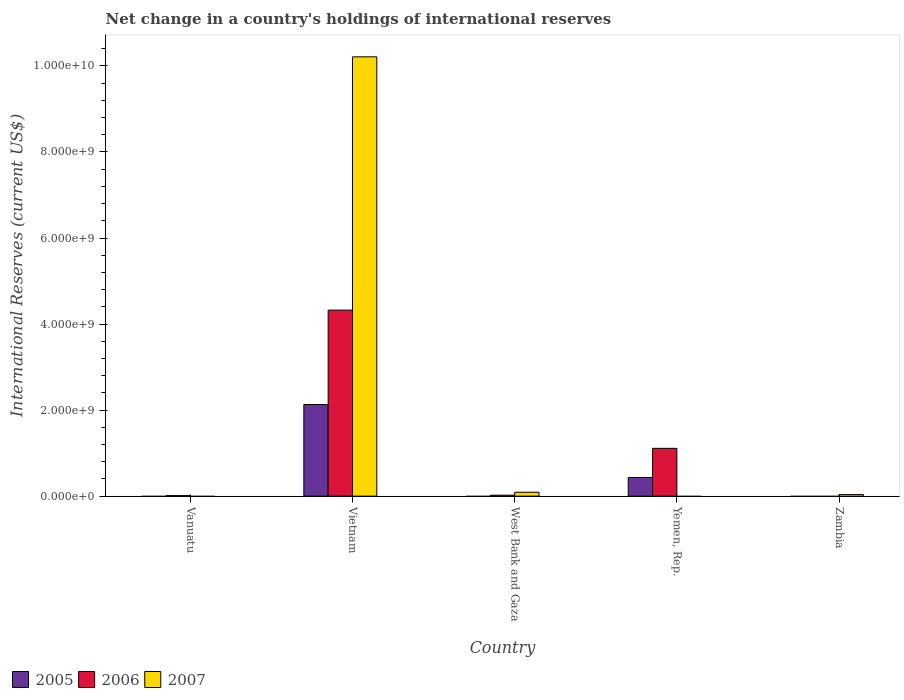What is the label of the 5th group of bars from the left?
Offer a very short reply. Zambia. In how many cases, is the number of bars for a given country not equal to the number of legend labels?
Your answer should be very brief. 4. What is the international reserves in 2007 in West Bank and Gaza?
Offer a terse response. 9.13e+07. Across all countries, what is the maximum international reserves in 2006?
Your response must be concise. 4.32e+09. Across all countries, what is the minimum international reserves in 2005?
Your answer should be compact. 0. In which country was the international reserves in 2005 maximum?
Your answer should be very brief. Vietnam. What is the total international reserves in 2005 in the graph?
Make the answer very short. 2.56e+09. What is the difference between the international reserves in 2006 in Vanuatu and that in Vietnam?
Offer a very short reply. -4.31e+09. What is the difference between the international reserves in 2007 in Vietnam and the international reserves in 2006 in Zambia?
Provide a succinct answer. 1.02e+1. What is the average international reserves in 2006 per country?
Your response must be concise. 1.09e+09. What is the difference between the international reserves of/in 2005 and international reserves of/in 2006 in Vietnam?
Make the answer very short. -2.19e+09. What is the ratio of the international reserves in 2005 in Vietnam to that in Yemen, Rep.?
Make the answer very short. 4.91. Is the international reserves in 2006 in West Bank and Gaza less than that in Yemen, Rep.?
Your response must be concise. Yes. What is the difference between the highest and the second highest international reserves in 2007?
Provide a succinct answer. -1.01e+1. What is the difference between the highest and the lowest international reserves in 2007?
Provide a succinct answer. 1.02e+1. In how many countries, is the international reserves in 2006 greater than the average international reserves in 2006 taken over all countries?
Give a very brief answer. 2. Is it the case that in every country, the sum of the international reserves in 2005 and international reserves in 2007 is greater than the international reserves in 2006?
Offer a very short reply. No. Are all the bars in the graph horizontal?
Make the answer very short. No. How many countries are there in the graph?
Ensure brevity in your answer.  5. What is the difference between two consecutive major ticks on the Y-axis?
Your answer should be compact. 2.00e+09. How many legend labels are there?
Provide a short and direct response. 3. How are the legend labels stacked?
Keep it short and to the point. Horizontal. What is the title of the graph?
Provide a short and direct response. Net change in a country's holdings of international reserves. What is the label or title of the X-axis?
Offer a terse response. Country. What is the label or title of the Y-axis?
Ensure brevity in your answer.  International Reserves (current US$). What is the International Reserves (current US$) in 2006 in Vanuatu?
Your response must be concise. 1.29e+07. What is the International Reserves (current US$) in 2005 in Vietnam?
Give a very brief answer. 2.13e+09. What is the International Reserves (current US$) in 2006 in Vietnam?
Provide a short and direct response. 4.32e+09. What is the International Reserves (current US$) in 2007 in Vietnam?
Keep it short and to the point. 1.02e+1. What is the International Reserves (current US$) in 2005 in West Bank and Gaza?
Your answer should be very brief. 0. What is the International Reserves (current US$) of 2006 in West Bank and Gaza?
Your answer should be compact. 2.23e+07. What is the International Reserves (current US$) in 2007 in West Bank and Gaza?
Provide a succinct answer. 9.13e+07. What is the International Reserves (current US$) in 2005 in Yemen, Rep.?
Make the answer very short. 4.34e+08. What is the International Reserves (current US$) of 2006 in Yemen, Rep.?
Your response must be concise. 1.11e+09. What is the International Reserves (current US$) in 2005 in Zambia?
Make the answer very short. 0. What is the International Reserves (current US$) in 2007 in Zambia?
Give a very brief answer. 3.68e+07. Across all countries, what is the maximum International Reserves (current US$) of 2005?
Provide a short and direct response. 2.13e+09. Across all countries, what is the maximum International Reserves (current US$) in 2006?
Give a very brief answer. 4.32e+09. Across all countries, what is the maximum International Reserves (current US$) of 2007?
Make the answer very short. 1.02e+1. What is the total International Reserves (current US$) in 2005 in the graph?
Keep it short and to the point. 2.56e+09. What is the total International Reserves (current US$) of 2006 in the graph?
Ensure brevity in your answer.  5.47e+09. What is the total International Reserves (current US$) of 2007 in the graph?
Your response must be concise. 1.03e+1. What is the difference between the International Reserves (current US$) in 2006 in Vanuatu and that in Vietnam?
Your answer should be compact. -4.31e+09. What is the difference between the International Reserves (current US$) of 2006 in Vanuatu and that in West Bank and Gaza?
Provide a short and direct response. -9.43e+06. What is the difference between the International Reserves (current US$) in 2006 in Vanuatu and that in Yemen, Rep.?
Ensure brevity in your answer.  -1.10e+09. What is the difference between the International Reserves (current US$) of 2006 in Vietnam and that in West Bank and Gaza?
Your response must be concise. 4.30e+09. What is the difference between the International Reserves (current US$) of 2007 in Vietnam and that in West Bank and Gaza?
Your answer should be compact. 1.01e+1. What is the difference between the International Reserves (current US$) in 2005 in Vietnam and that in Yemen, Rep.?
Provide a short and direct response. 1.70e+09. What is the difference between the International Reserves (current US$) of 2006 in Vietnam and that in Yemen, Rep.?
Your response must be concise. 3.21e+09. What is the difference between the International Reserves (current US$) of 2007 in Vietnam and that in Zambia?
Make the answer very short. 1.02e+1. What is the difference between the International Reserves (current US$) of 2006 in West Bank and Gaza and that in Yemen, Rep.?
Your response must be concise. -1.09e+09. What is the difference between the International Reserves (current US$) of 2007 in West Bank and Gaza and that in Zambia?
Offer a very short reply. 5.45e+07. What is the difference between the International Reserves (current US$) of 2006 in Vanuatu and the International Reserves (current US$) of 2007 in Vietnam?
Your response must be concise. -1.02e+1. What is the difference between the International Reserves (current US$) of 2006 in Vanuatu and the International Reserves (current US$) of 2007 in West Bank and Gaza?
Give a very brief answer. -7.84e+07. What is the difference between the International Reserves (current US$) in 2006 in Vanuatu and the International Reserves (current US$) in 2007 in Zambia?
Provide a succinct answer. -2.39e+07. What is the difference between the International Reserves (current US$) of 2005 in Vietnam and the International Reserves (current US$) of 2006 in West Bank and Gaza?
Offer a terse response. 2.11e+09. What is the difference between the International Reserves (current US$) in 2005 in Vietnam and the International Reserves (current US$) in 2007 in West Bank and Gaza?
Provide a succinct answer. 2.04e+09. What is the difference between the International Reserves (current US$) in 2006 in Vietnam and the International Reserves (current US$) in 2007 in West Bank and Gaza?
Your answer should be compact. 4.23e+09. What is the difference between the International Reserves (current US$) of 2005 in Vietnam and the International Reserves (current US$) of 2006 in Yemen, Rep.?
Your answer should be very brief. 1.02e+09. What is the difference between the International Reserves (current US$) of 2005 in Vietnam and the International Reserves (current US$) of 2007 in Zambia?
Offer a very short reply. 2.09e+09. What is the difference between the International Reserves (current US$) in 2006 in Vietnam and the International Reserves (current US$) in 2007 in Zambia?
Give a very brief answer. 4.29e+09. What is the difference between the International Reserves (current US$) of 2006 in West Bank and Gaza and the International Reserves (current US$) of 2007 in Zambia?
Give a very brief answer. -1.45e+07. What is the difference between the International Reserves (current US$) in 2005 in Yemen, Rep. and the International Reserves (current US$) in 2007 in Zambia?
Ensure brevity in your answer.  3.97e+08. What is the difference between the International Reserves (current US$) of 2006 in Yemen, Rep. and the International Reserves (current US$) of 2007 in Zambia?
Provide a short and direct response. 1.07e+09. What is the average International Reserves (current US$) in 2005 per country?
Give a very brief answer. 5.13e+08. What is the average International Reserves (current US$) of 2006 per country?
Offer a terse response. 1.09e+09. What is the average International Reserves (current US$) in 2007 per country?
Offer a terse response. 2.07e+09. What is the difference between the International Reserves (current US$) of 2005 and International Reserves (current US$) of 2006 in Vietnam?
Your answer should be very brief. -2.19e+09. What is the difference between the International Reserves (current US$) of 2005 and International Reserves (current US$) of 2007 in Vietnam?
Your response must be concise. -8.08e+09. What is the difference between the International Reserves (current US$) of 2006 and International Reserves (current US$) of 2007 in Vietnam?
Your answer should be compact. -5.89e+09. What is the difference between the International Reserves (current US$) in 2006 and International Reserves (current US$) in 2007 in West Bank and Gaza?
Offer a terse response. -6.90e+07. What is the difference between the International Reserves (current US$) in 2005 and International Reserves (current US$) in 2006 in Yemen, Rep.?
Your answer should be very brief. -6.78e+08. What is the ratio of the International Reserves (current US$) of 2006 in Vanuatu to that in Vietnam?
Give a very brief answer. 0. What is the ratio of the International Reserves (current US$) in 2006 in Vanuatu to that in West Bank and Gaza?
Ensure brevity in your answer.  0.58. What is the ratio of the International Reserves (current US$) in 2006 in Vanuatu to that in Yemen, Rep.?
Your response must be concise. 0.01. What is the ratio of the International Reserves (current US$) of 2006 in Vietnam to that in West Bank and Gaza?
Your response must be concise. 193.78. What is the ratio of the International Reserves (current US$) of 2007 in Vietnam to that in West Bank and Gaza?
Offer a very short reply. 111.87. What is the ratio of the International Reserves (current US$) in 2005 in Vietnam to that in Yemen, Rep.?
Give a very brief answer. 4.91. What is the ratio of the International Reserves (current US$) in 2006 in Vietnam to that in Yemen, Rep.?
Your answer should be compact. 3.89. What is the ratio of the International Reserves (current US$) of 2007 in Vietnam to that in Zambia?
Make the answer very short. 277.4. What is the ratio of the International Reserves (current US$) in 2006 in West Bank and Gaza to that in Yemen, Rep.?
Provide a succinct answer. 0.02. What is the ratio of the International Reserves (current US$) of 2007 in West Bank and Gaza to that in Zambia?
Offer a very short reply. 2.48. What is the difference between the highest and the second highest International Reserves (current US$) of 2006?
Offer a terse response. 3.21e+09. What is the difference between the highest and the second highest International Reserves (current US$) of 2007?
Offer a very short reply. 1.01e+1. What is the difference between the highest and the lowest International Reserves (current US$) of 2005?
Your answer should be compact. 2.13e+09. What is the difference between the highest and the lowest International Reserves (current US$) in 2006?
Provide a succinct answer. 4.32e+09. What is the difference between the highest and the lowest International Reserves (current US$) of 2007?
Give a very brief answer. 1.02e+1. 